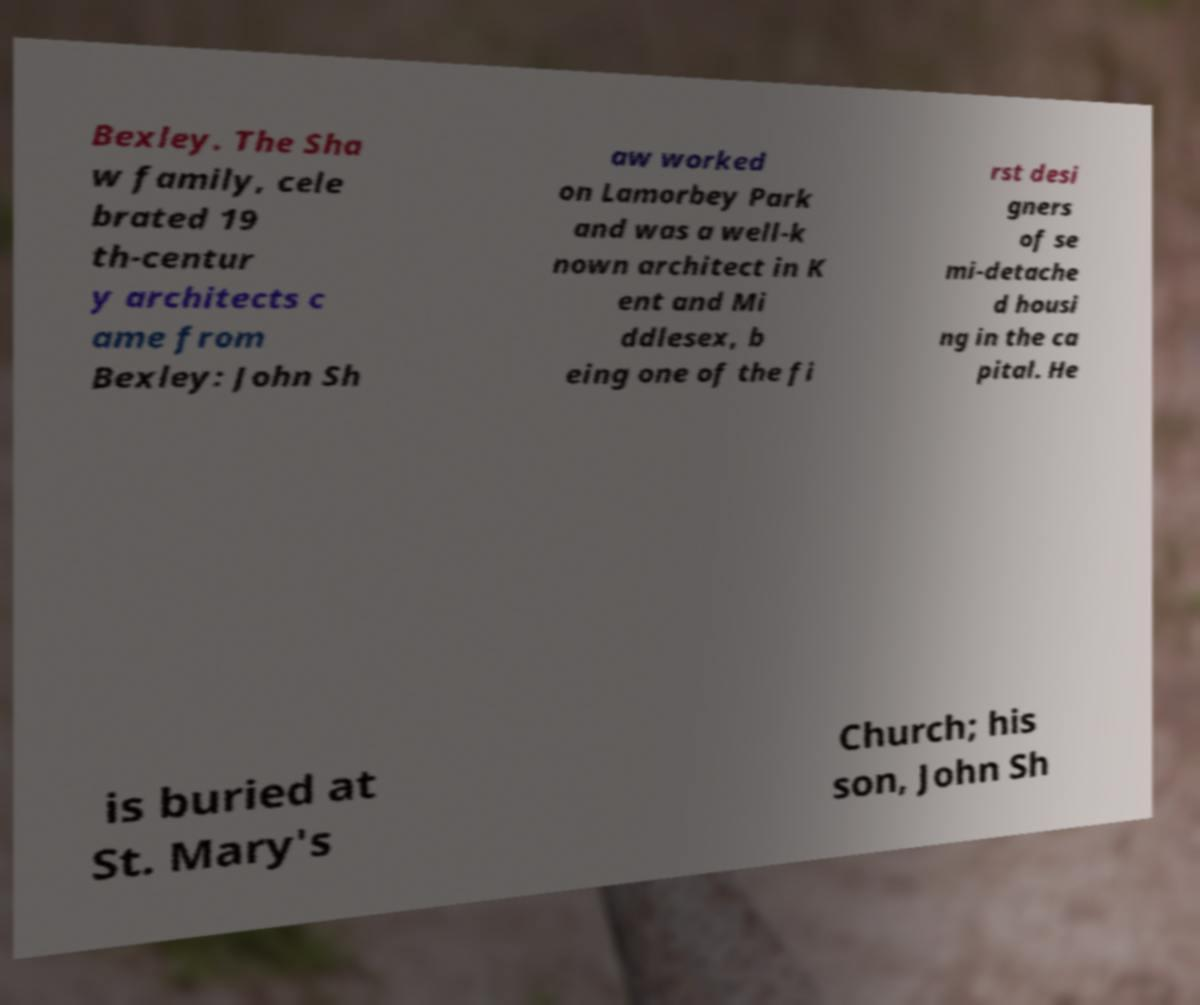Could you assist in decoding the text presented in this image and type it out clearly? Bexley. The Sha w family, cele brated 19 th-centur y architects c ame from Bexley: John Sh aw worked on Lamorbey Park and was a well-k nown architect in K ent and Mi ddlesex, b eing one of the fi rst desi gners of se mi-detache d housi ng in the ca pital. He is buried at St. Mary's Church; his son, John Sh 